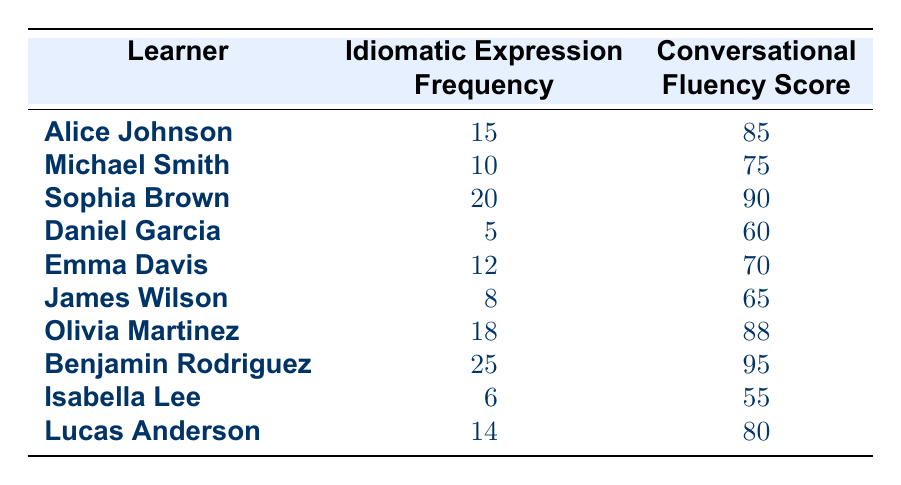What is the highest conversational fluency score among the learners? By inspecting the "Conversational Fluency Score" column, the highest value is 95, which corresponds to Benjamin Rodriguez.
Answer: 95 What is the idiomatic expression frequency of Sophia Brown? Looking at the table, under "Idiomatic Expression Frequency," Sophia Brown has a frequency of 20.
Answer: 20 Is the idiomatic expression frequency of Alice Johnson greater than 12? Alice Johnson has an idiomatic expression frequency of 15, which is indeed greater than 12. Therefore, the statement is true.
Answer: Yes Calculate the average idiomatic expression frequency of all learners. To find the average, sum the frequencies: 15 + 10 + 20 + 5 + 12 + 8 + 18 + 25 + 6 + 14 = 129. There are 10 learners, so the average is 129/10 = 12.9.
Answer: 12.9 Who has the lowest conversational fluency score, and what is the score? Scanning through the "Conversational Fluency Score" column, Isabella Lee has the lowest score of 55.
Answer: Isabella Lee, 55 How many learners have a conversational fluency score above 80? By reviewing the scores: 85, 90, 88, 95, and 80 from the table, there are 5 learners (Alice Johnson, Sophia Brown, Olivia Martinez, Benjamin Rodriguez, Lucas Anderson) with scores exceeding 80.
Answer: 5 Is there a learner with an idiomatic expression frequency of exactly 6? Checking the table, Isabella Lee has an idiomatic expression frequency of 6, confirming the statement as true.
Answer: Yes What is the difference in conversational fluency scores between the learner with the highest and the one with the lowest scores? The highest score is 95 (Benjamin Rodriguez) and the lowest is 55 (Isabella Lee). The difference is 95 - 55 = 40.
Answer: 40 What percentage of learners have an idiomatic expression frequency of 15 or more? The learners with 15 or more frequencies are Alice Johnson, Sophia Brown, Olivia Martinez, and Benjamin Rodriguez (4 learners). There are 10 learners total, so the percentage is (4/10) * 100 = 40%.
Answer: 40% 